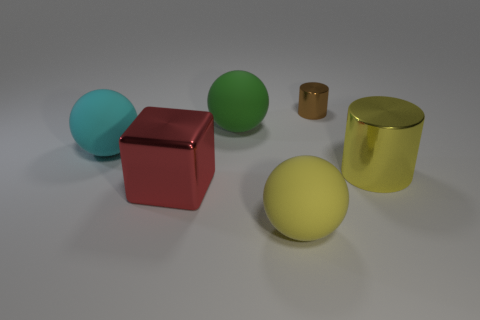Add 2 blocks. How many objects exist? 8 Subtract all blue cubes. Subtract all purple balls. How many cubes are left? 1 Subtract all cubes. How many objects are left? 5 Add 3 tiny cyan things. How many tiny cyan things exist? 3 Subtract 0 purple balls. How many objects are left? 6 Subtract all big cyan balls. Subtract all yellow cylinders. How many objects are left? 4 Add 6 brown cylinders. How many brown cylinders are left? 7 